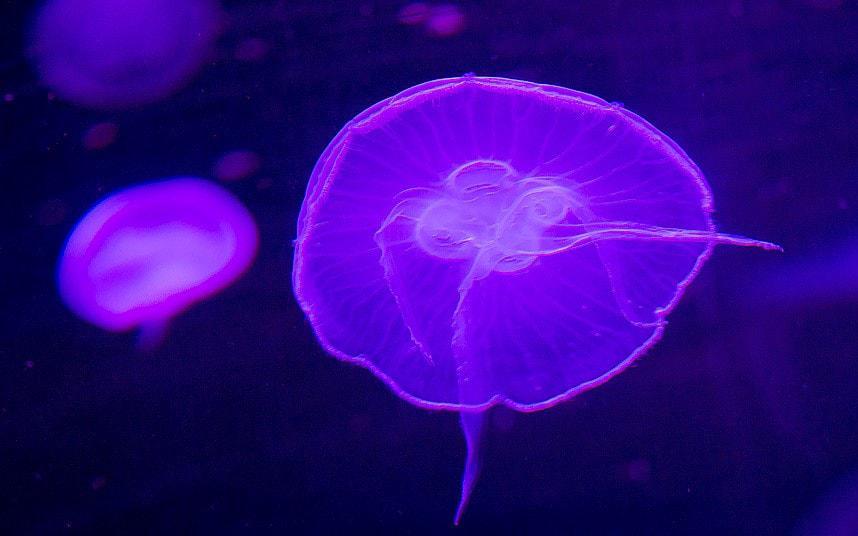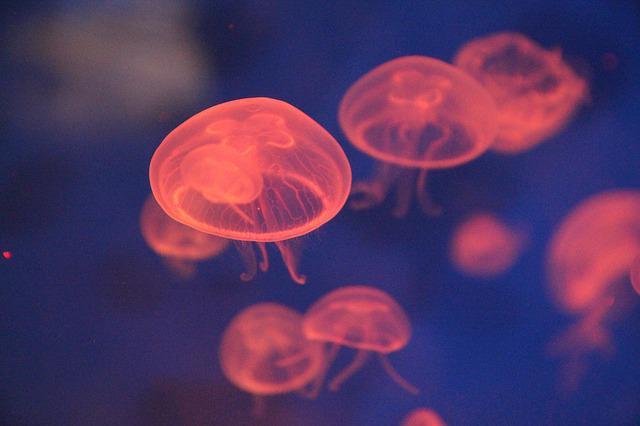The first image is the image on the left, the second image is the image on the right. Given the left and right images, does the statement "An image shows a single jellyfish trailing something frilly and foamy looking." hold true? Answer yes or no. No. 